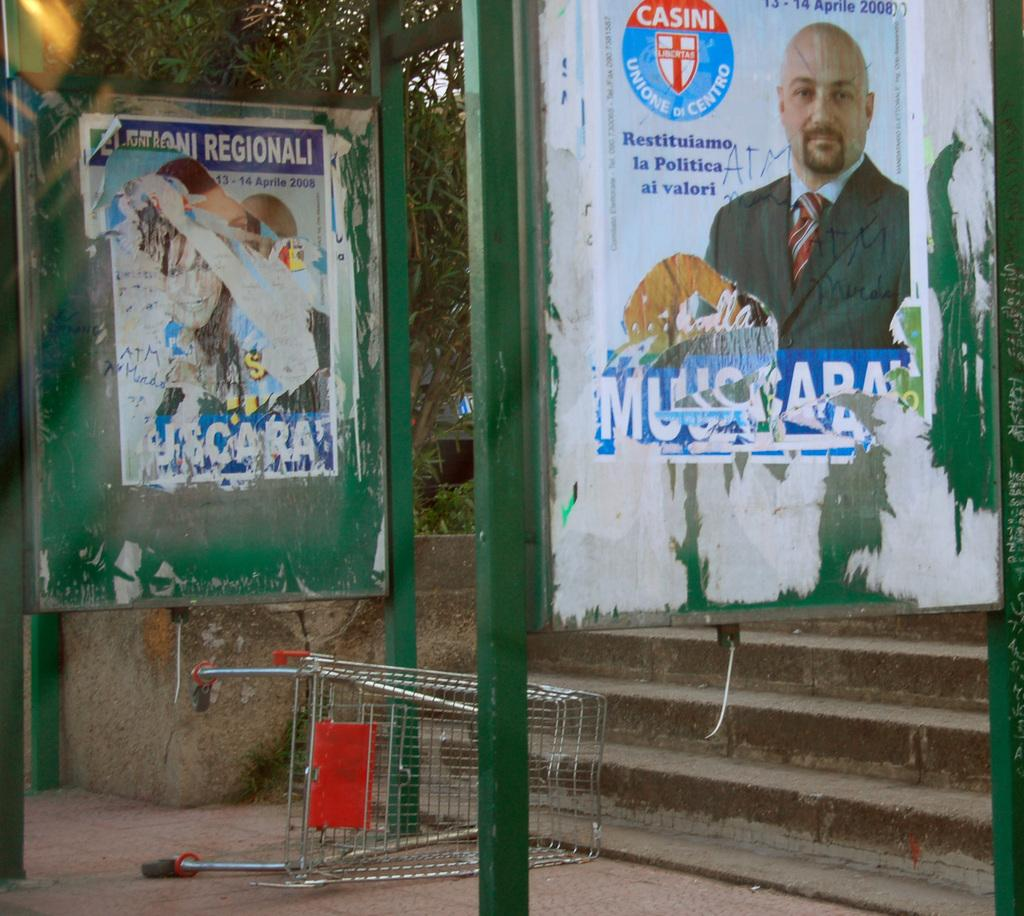Provide a one-sentence caption for the provided image. A sidewalk and stairs are seen under a poster with the Casini logo on it. 